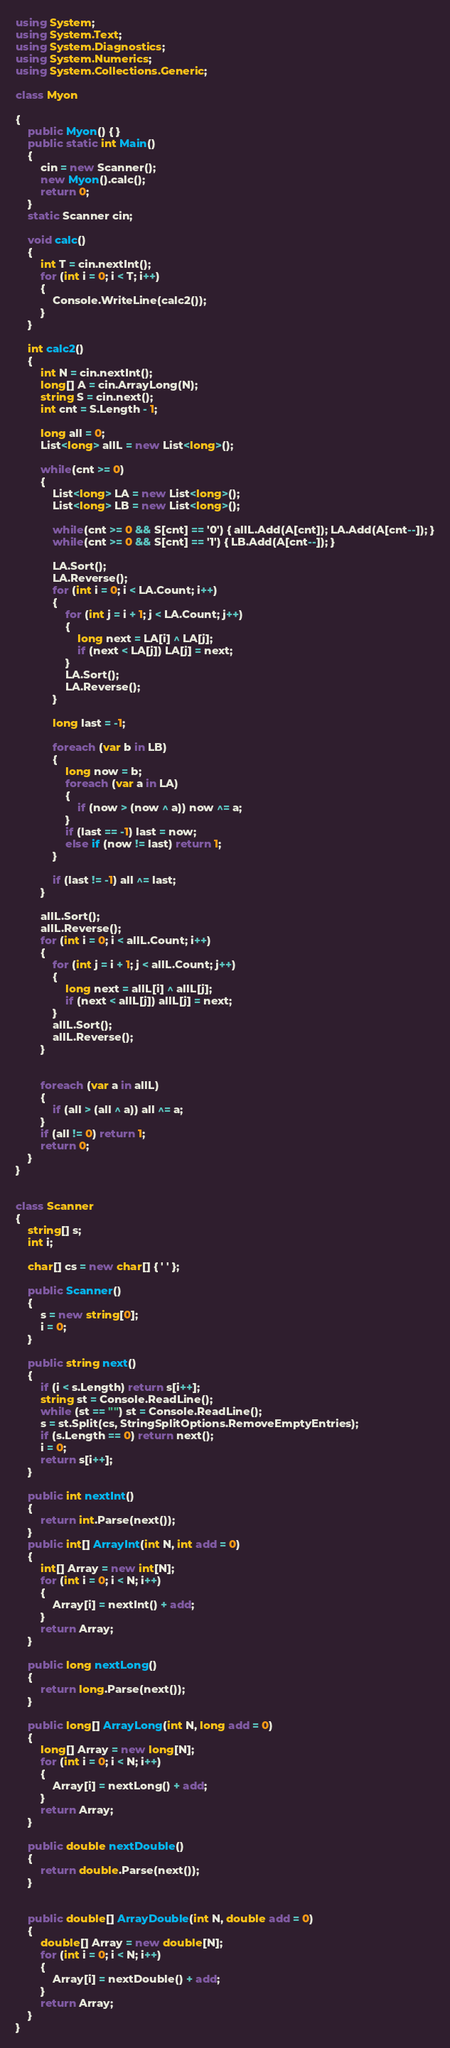Convert code to text. <code><loc_0><loc_0><loc_500><loc_500><_C#_>using System;
using System.Text;
using System.Diagnostics;
using System.Numerics;
using System.Collections.Generic;

class Myon

{
    public Myon() { }
    public static int Main()
    {
        cin = new Scanner();
        new Myon().calc();
        return 0;
    }
    static Scanner cin;

    void calc()
    {
        int T = cin.nextInt();
        for (int i = 0; i < T; i++)
        {
            Console.WriteLine(calc2());
        }
    }

    int calc2()
    {
        int N = cin.nextInt();
        long[] A = cin.ArrayLong(N);
        string S = cin.next();
        int cnt = S.Length - 1;

        long all = 0;
        List<long> allL = new List<long>();

        while(cnt >= 0)
        {
            List<long> LA = new List<long>();
            List<long> LB = new List<long>();

            while(cnt >= 0 && S[cnt] == '0') { allL.Add(A[cnt]); LA.Add(A[cnt--]); }
            while(cnt >= 0 && S[cnt] == '1') { LB.Add(A[cnt--]); }

            LA.Sort();
            LA.Reverse();
            for (int i = 0; i < LA.Count; i++)
            {
                for (int j = i + 1; j < LA.Count; j++)
                {
                    long next = LA[i] ^ LA[j];
                    if (next < LA[j]) LA[j] = next;
                }
                LA.Sort();
                LA.Reverse();
            }

            long last = -1;

            foreach (var b in LB)
            {
                long now = b;
                foreach (var a in LA)
                {
                    if (now > (now ^ a)) now ^= a;
                }
                if (last == -1) last = now;
                else if (now != last) return 1;
            }

            if (last != -1) all ^= last;
        }

        allL.Sort();
        allL.Reverse();
        for (int i = 0; i < allL.Count; i++)
        {
            for (int j = i + 1; j < allL.Count; j++)
            {
                long next = allL[i] ^ allL[j];
                if (next < allL[j]) allL[j] = next;
            }
            allL.Sort();
            allL.Reverse();
        }


        foreach (var a in allL)
        {
            if (all > (all ^ a)) all ^= a;
        }
        if (all != 0) return 1;
        return 0;
    }
}


class Scanner
{
    string[] s;
    int i;

    char[] cs = new char[] { ' ' };

    public Scanner()
    {
        s = new string[0];
        i = 0;
    }

    public string next()
    {
        if (i < s.Length) return s[i++];
        string st = Console.ReadLine();
        while (st == "") st = Console.ReadLine();
        s = st.Split(cs, StringSplitOptions.RemoveEmptyEntries);
        if (s.Length == 0) return next();
        i = 0;
        return s[i++];
    }

    public int nextInt()
    {
        return int.Parse(next());
    }
    public int[] ArrayInt(int N, int add = 0)
    {
        int[] Array = new int[N];
        for (int i = 0; i < N; i++)
        {
            Array[i] = nextInt() + add;
        }
        return Array;
    }

    public long nextLong()
    {
        return long.Parse(next());
    }

    public long[] ArrayLong(int N, long add = 0)
    {
        long[] Array = new long[N];
        for (int i = 0; i < N; i++)
        {
            Array[i] = nextLong() + add;
        }
        return Array;
    }

    public double nextDouble()
    {
        return double.Parse(next());
    }


    public double[] ArrayDouble(int N, double add = 0)
    {
        double[] Array = new double[N];
        for (int i = 0; i < N; i++)
        {
            Array[i] = nextDouble() + add;
        }
        return Array;
    }
}
</code> 